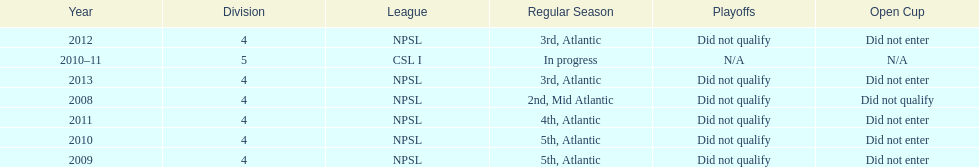What was the last year they were 5th? 2010. 